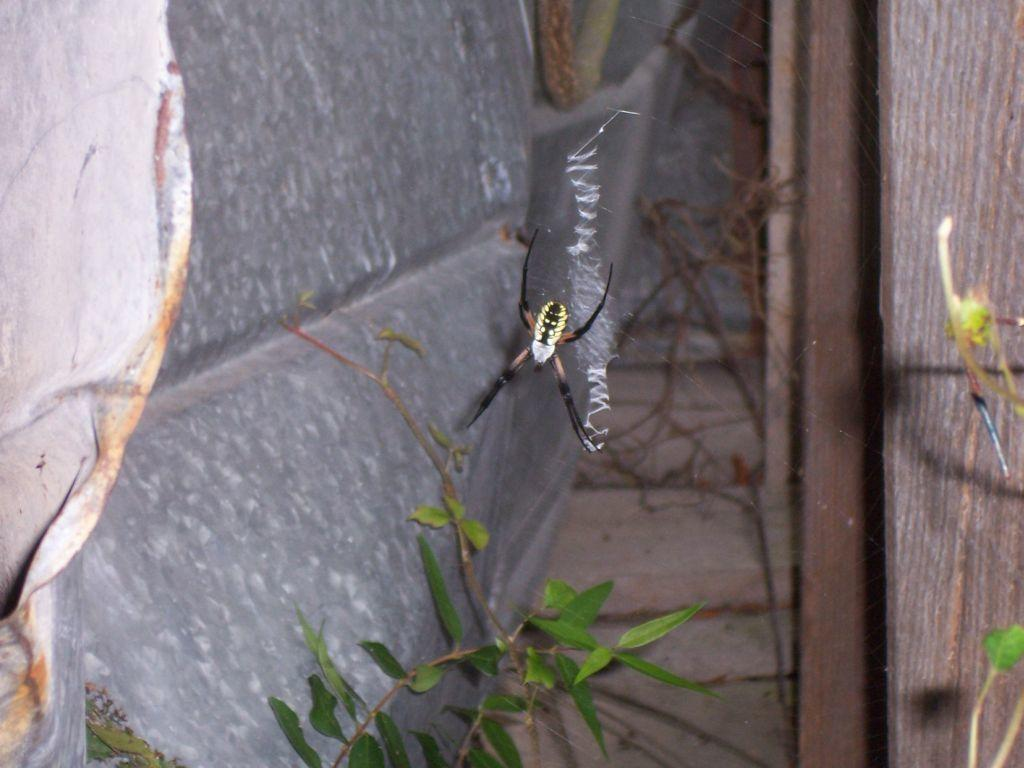What is present in the web in the image? There is a spider in the web in the image. What other elements can be seen in the image besides the spider? There are leaves of a plant in the image. What type of fuel is being used by the spider to spin its web in the image? There is no indication in the image that the spider is using any fuel to spin its web. Spiders produce silk naturally to create their webs. 